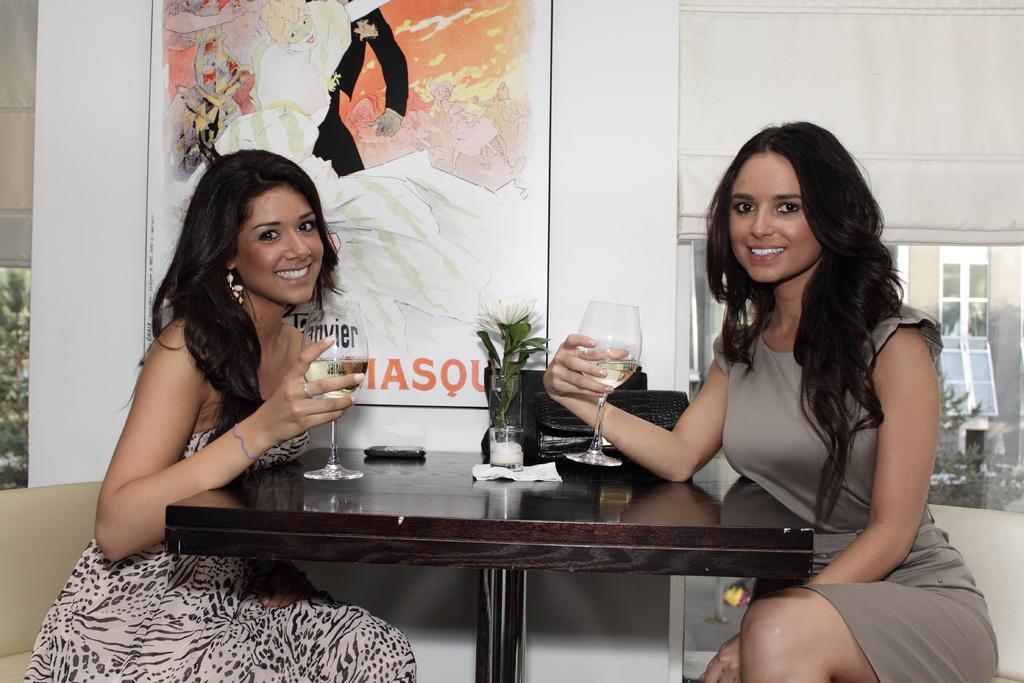Describe this image in one or two sentences. In this image there are two lady persons sitting on the chair and having their drinks and at the background of the image there is a painting. 